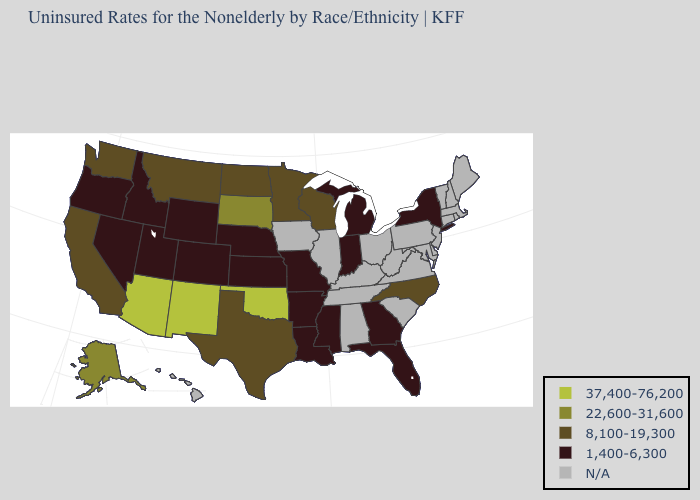Name the states that have a value in the range 1,400-6,300?
Write a very short answer. Arkansas, Colorado, Florida, Georgia, Idaho, Indiana, Kansas, Louisiana, Michigan, Mississippi, Missouri, Nebraska, Nevada, New York, Oregon, Utah, Wyoming. Name the states that have a value in the range 1,400-6,300?
Write a very short answer. Arkansas, Colorado, Florida, Georgia, Idaho, Indiana, Kansas, Louisiana, Michigan, Mississippi, Missouri, Nebraska, Nevada, New York, Oregon, Utah, Wyoming. What is the value of Oregon?
Be succinct. 1,400-6,300. Does Alaska have the highest value in the West?
Write a very short answer. No. Name the states that have a value in the range 8,100-19,300?
Concise answer only. California, Minnesota, Montana, North Carolina, North Dakota, Texas, Washington, Wisconsin. Among the states that border Virginia , which have the highest value?
Keep it brief. North Carolina. What is the lowest value in the USA?
Concise answer only. 1,400-6,300. Does California have the lowest value in the West?
Answer briefly. No. What is the highest value in the West ?
Concise answer only. 37,400-76,200. Which states have the lowest value in the South?
Short answer required. Arkansas, Florida, Georgia, Louisiana, Mississippi. Does the first symbol in the legend represent the smallest category?
Answer briefly. No. What is the value of Rhode Island?
Quick response, please. N/A. Among the states that border Nevada , does California have the highest value?
Be succinct. No. What is the lowest value in states that border Nebraska?
Short answer required. 1,400-6,300. 